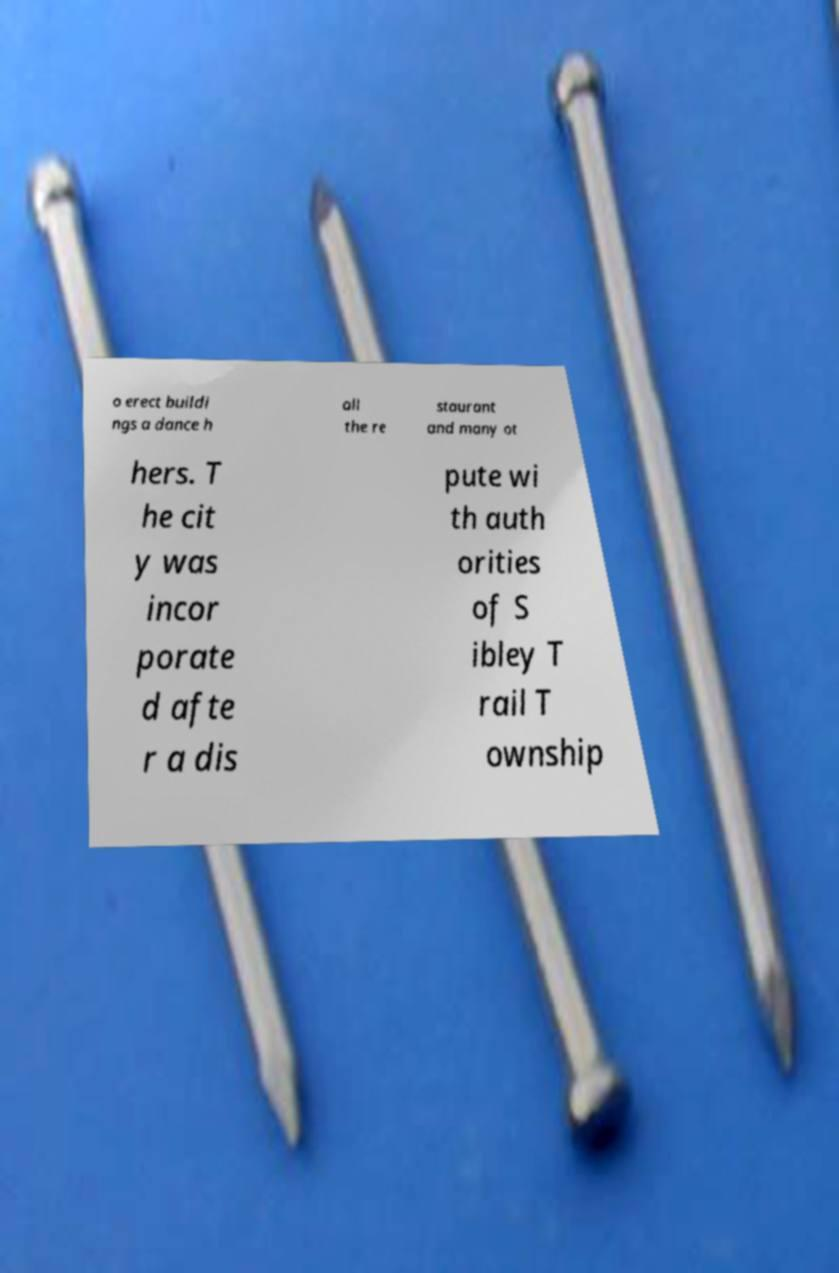Could you extract and type out the text from this image? o erect buildi ngs a dance h all the re staurant and many ot hers. T he cit y was incor porate d afte r a dis pute wi th auth orities of S ibley T rail T ownship 